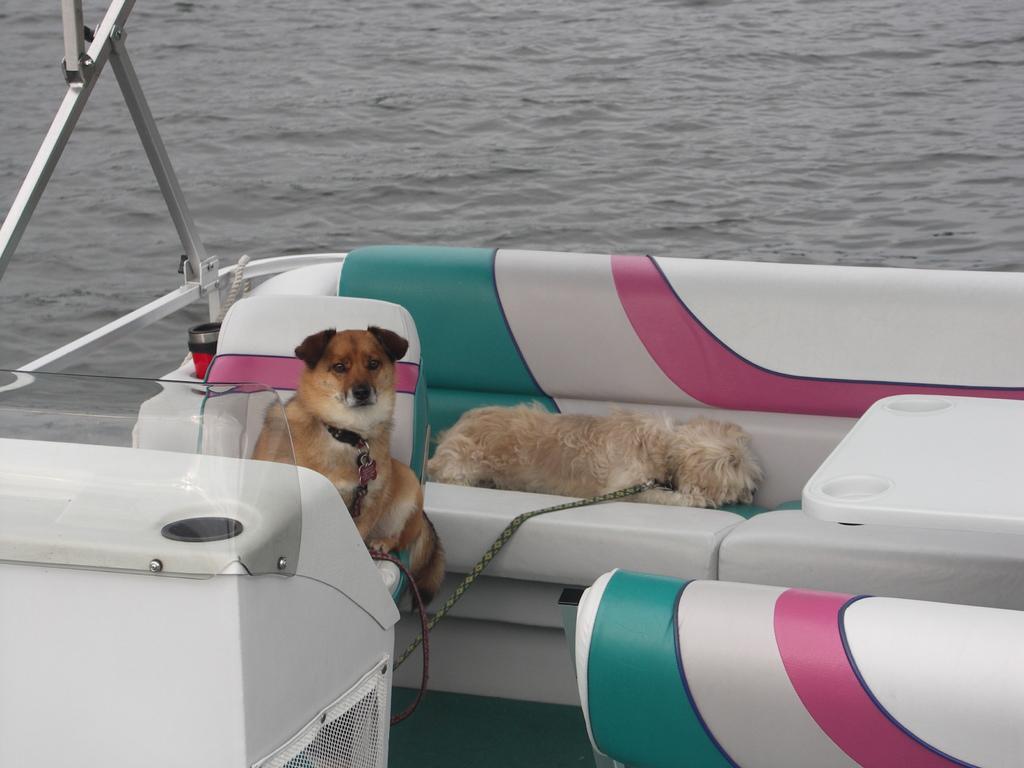Please provide a concise description of this image. This image consists of two dogs in the boat. They are tied with the belts. In the front, we can see the seats along with the table. At the bottom, there is water. On the left, there are metal rods. 